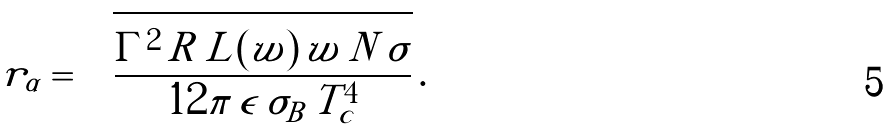<formula> <loc_0><loc_0><loc_500><loc_500>\tilde { r } _ { \alpha } = \sqrt { \frac { \Gamma ^ { 2 } \, R \, L ( w ) \, w \, N \, \sigma } { 1 2 \pi \, \epsilon \, \sigma _ { B } \, T ^ { 4 } _ { c } } } \, .</formula> 